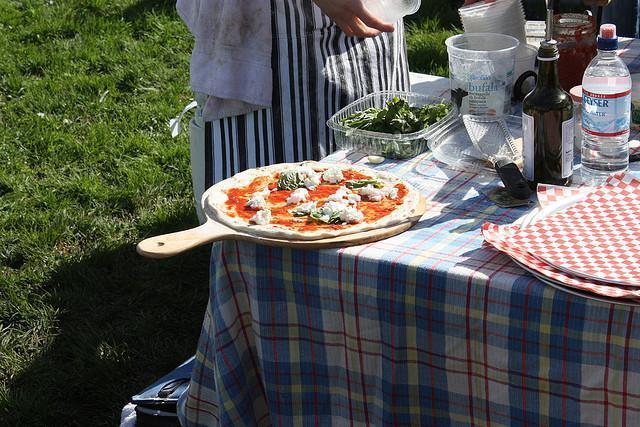Is the caption "The pizza is at the edge of the dining table." a true representation of the image?
Answer yes or no. Yes. 